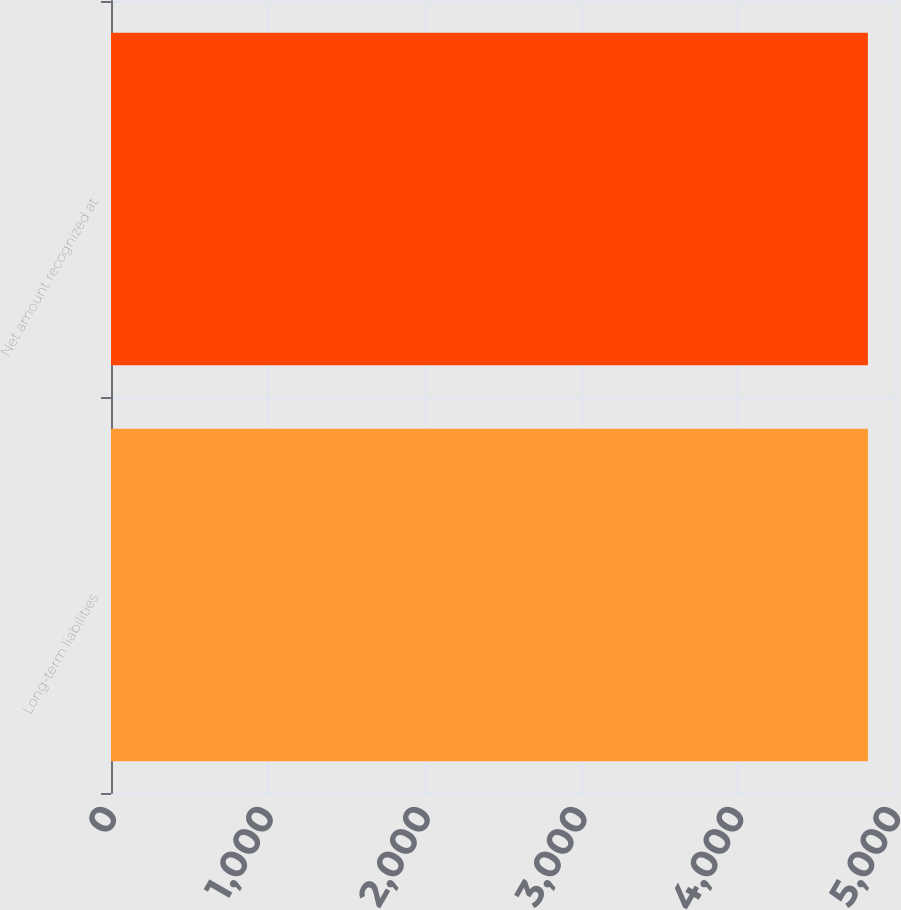<chart> <loc_0><loc_0><loc_500><loc_500><bar_chart><fcel>Long-term liabilities<fcel>Net amount recognized at<nl><fcel>4827<fcel>4827.1<nl></chart> 